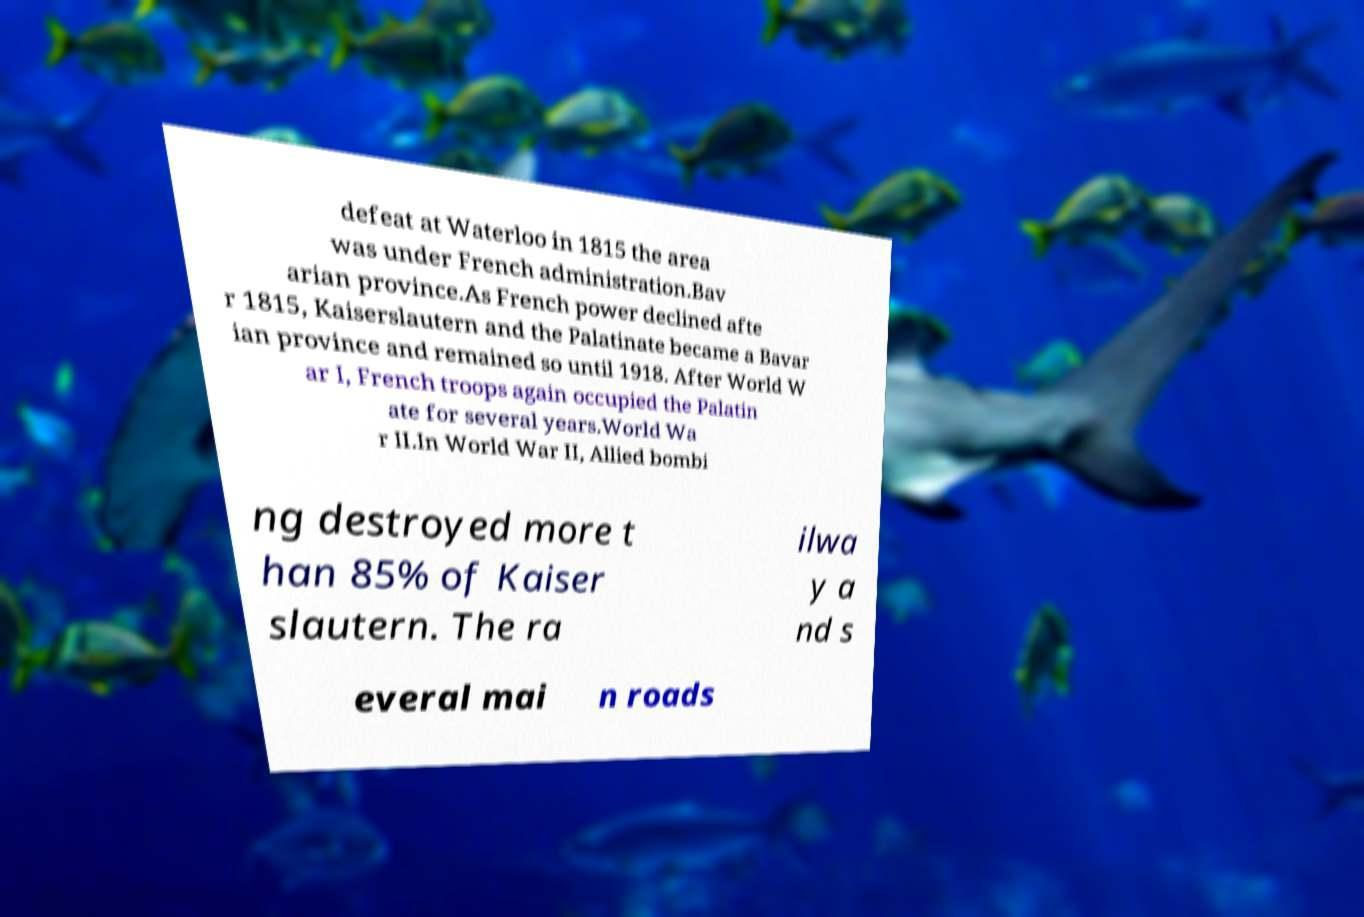I need the written content from this picture converted into text. Can you do that? defeat at Waterloo in 1815 the area was under French administration.Bav arian province.As French power declined afte r 1815, Kaiserslautern and the Palatinate became a Bavar ian province and remained so until 1918. After World W ar I, French troops again occupied the Palatin ate for several years.World Wa r II.In World War II, Allied bombi ng destroyed more t han 85% of Kaiser slautern. The ra ilwa y a nd s everal mai n roads 